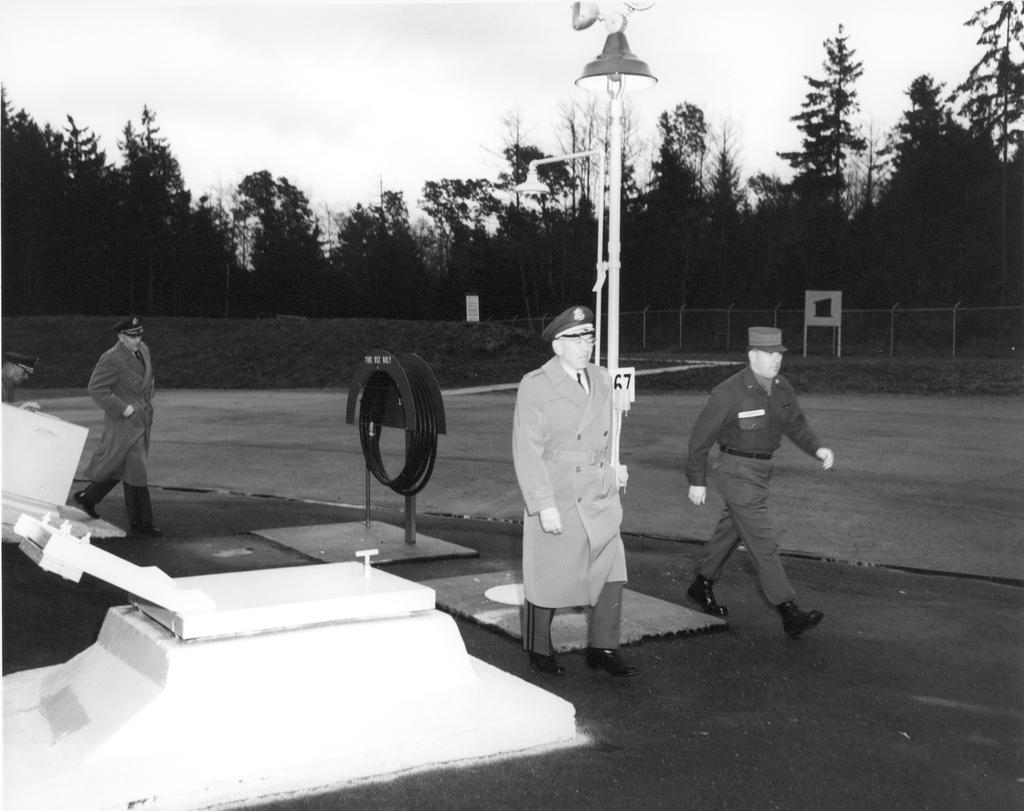What is the color scheme of the image? The image is black and white. What are the people in the image doing? There are people walking in the image. What can be seen in the background of the image? In the background of the image, there are poles, bushes, trees, fences, boards, and other objects. How many goldfish are swimming in the image? There are no goldfish present in the image. What type of mask is being worn by the people in the image? There are no masks visible in the image; the people are walking without any masks. 